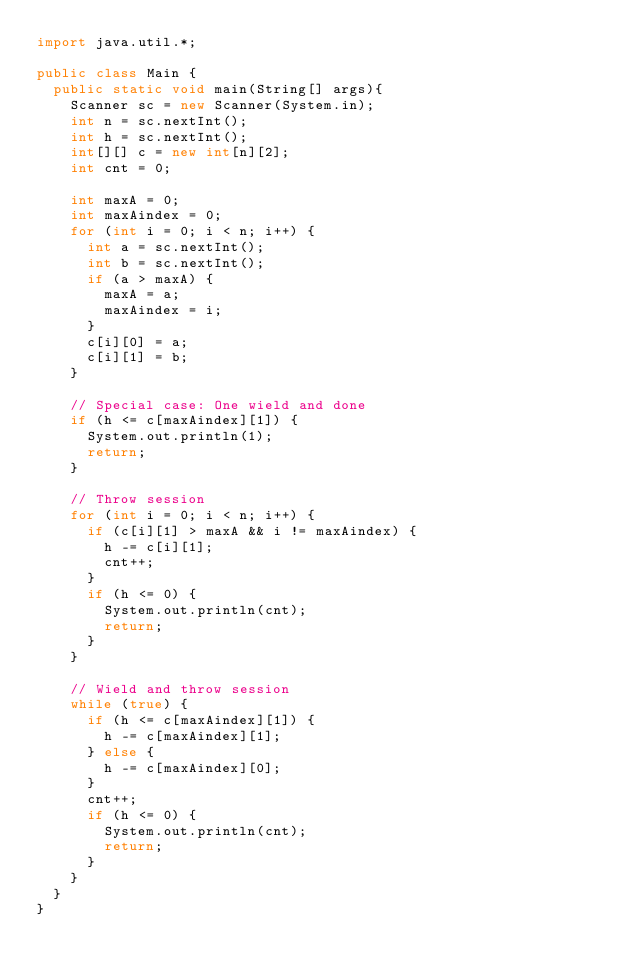Convert code to text. <code><loc_0><loc_0><loc_500><loc_500><_Java_>import java.util.*;

public class Main {
	public static void main(String[] args){
    Scanner sc = new Scanner(System.in);
    int n = sc.nextInt();
		int h = sc.nextInt();
		int[][] c = new int[n][2];
		int cnt = 0;

		int maxA = 0;
		int maxAindex = 0;
		for (int i = 0; i < n; i++) {
			int a = sc.nextInt();
			int b = sc.nextInt();
			if (a > maxA) {
				maxA = a;
				maxAindex = i;
			}
			c[i][0] = a;
			c[i][1] = b;
		}

		// Special case: One wield and done
		if (h <= c[maxAindex][1]) {
			System.out.println(1);
			return;
		}

		// Throw session
		for (int i = 0; i < n; i++) {
			if (c[i][1] > maxA && i != maxAindex) {
				h -= c[i][1];
				cnt++;
			}
			if (h <= 0) {
				System.out.println(cnt);
				return;
			}
		}

		// Wield and throw session
		while (true) {
			if (h <= c[maxAindex][1]) {
				h -= c[maxAindex][1];
			} else {
				h -= c[maxAindex][0];
			}
			cnt++;
			if (h <= 0) {
				System.out.println(cnt);
				return;
			}
		}
  }
}
</code> 